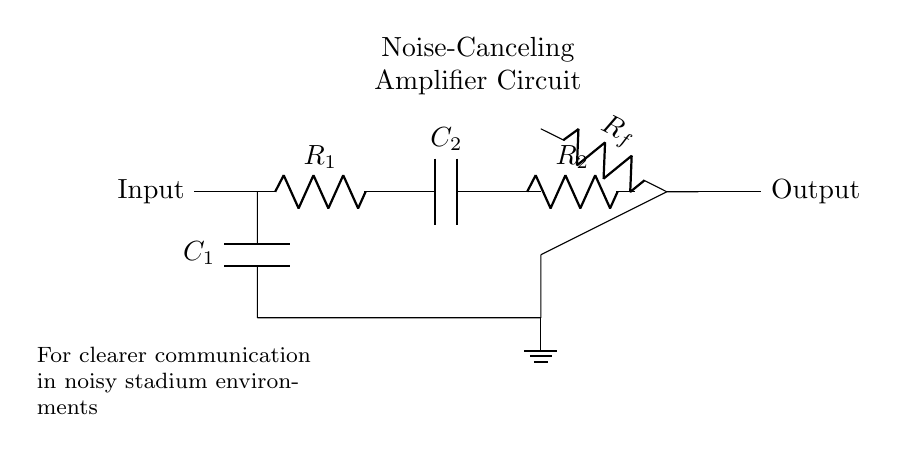What is the function of the capacitor C1? C1 is used to block DC while allowing AC signals to pass through, which is essential for noise-canceling applications.
Answer: Block DC What do R1 and R2 represent in this circuit? R1 and R2 are resistors that are part of the noise-canceling amplifier setup, helping to set the gain and establish frequency response.
Answer: Resistors How many capacitors are present in the circuit? There are two capacitors, C1 and C2, utilized in the noise-canceling process.
Answer: Two What is the gain-setting component in this circuit? The gain-setting component is the resistor Rf, placed in the feedback loop of the op-amp, which influences the amplification level.
Answer: Rf What type of circuit is this diagram representing? The diagram represents a noise-canceling amplifier circuit, designed to improve communication in environments with background noise.
Answer: Noise-canceling amplifier What role does the op-amp play in this circuit? The op-amp amplifies the input signal while canceling out noise, enhancing the clarity of the communication signal.
Answer: Amplifies signal 